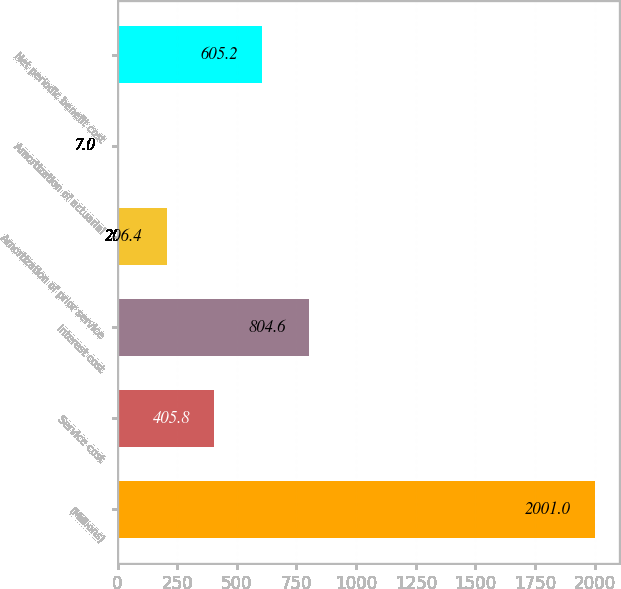Convert chart. <chart><loc_0><loc_0><loc_500><loc_500><bar_chart><fcel>(Millions)<fcel>Service cost<fcel>Interest cost<fcel>Amortization of prior service<fcel>Amortization of actuarial<fcel>Net periodic benefit cost<nl><fcel>2001<fcel>405.8<fcel>804.6<fcel>206.4<fcel>7<fcel>605.2<nl></chart> 